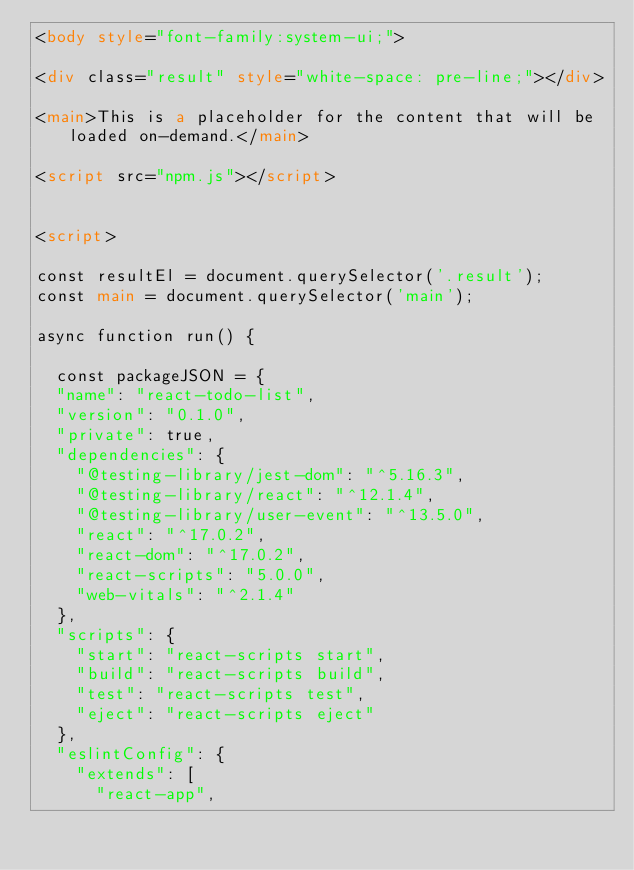<code> <loc_0><loc_0><loc_500><loc_500><_HTML_><body style="font-family:system-ui;">

<div class="result" style="white-space: pre-line;"></div>

<main>This is a placeholder for the content that will be loaded on-demand.</main>

<script src="npm.js"></script>


<script>

const resultEl = document.querySelector('.result');
const main = document.querySelector('main');

async function run() {
  
  const packageJSON = {
  "name": "react-todo-list",
  "version": "0.1.0",
  "private": true,
  "dependencies": {
    "@testing-library/jest-dom": "^5.16.3",
    "@testing-library/react": "^12.1.4",
    "@testing-library/user-event": "^13.5.0",
    "react": "^17.0.2",
    "react-dom": "^17.0.2",
    "react-scripts": "5.0.0",
    "web-vitals": "^2.1.4"
  },
  "scripts": {
    "start": "react-scripts start",
    "build": "react-scripts build",
    "test": "react-scripts test",
    "eject": "react-scripts eject"
  },
  "eslintConfig": {
    "extends": [
      "react-app",</code> 